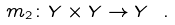Convert formula to latex. <formula><loc_0><loc_0><loc_500><loc_500>m _ { 2 } \colon Y \times Y \to Y \ .</formula> 